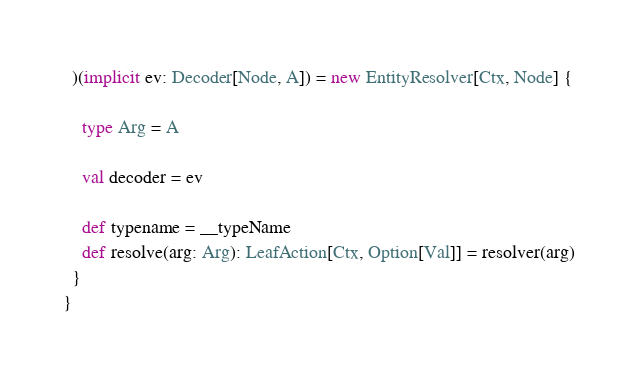<code> <loc_0><loc_0><loc_500><loc_500><_Scala_>  )(implicit ev: Decoder[Node, A]) = new EntityResolver[Ctx, Node] {

    type Arg = A

    val decoder = ev

    def typename = __typeName
    def resolve(arg: Arg): LeafAction[Ctx, Option[Val]] = resolver(arg)
  }
}
</code> 